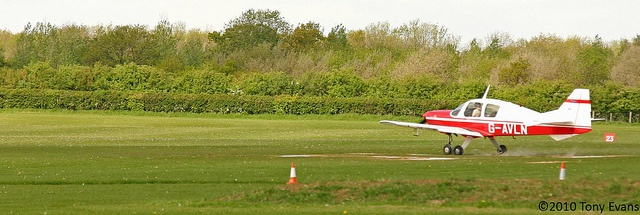Describe the objects in this image and their specific colors. I can see airplane in white, red, lightpink, and salmon tones and people in white, tan, and gray tones in this image. 